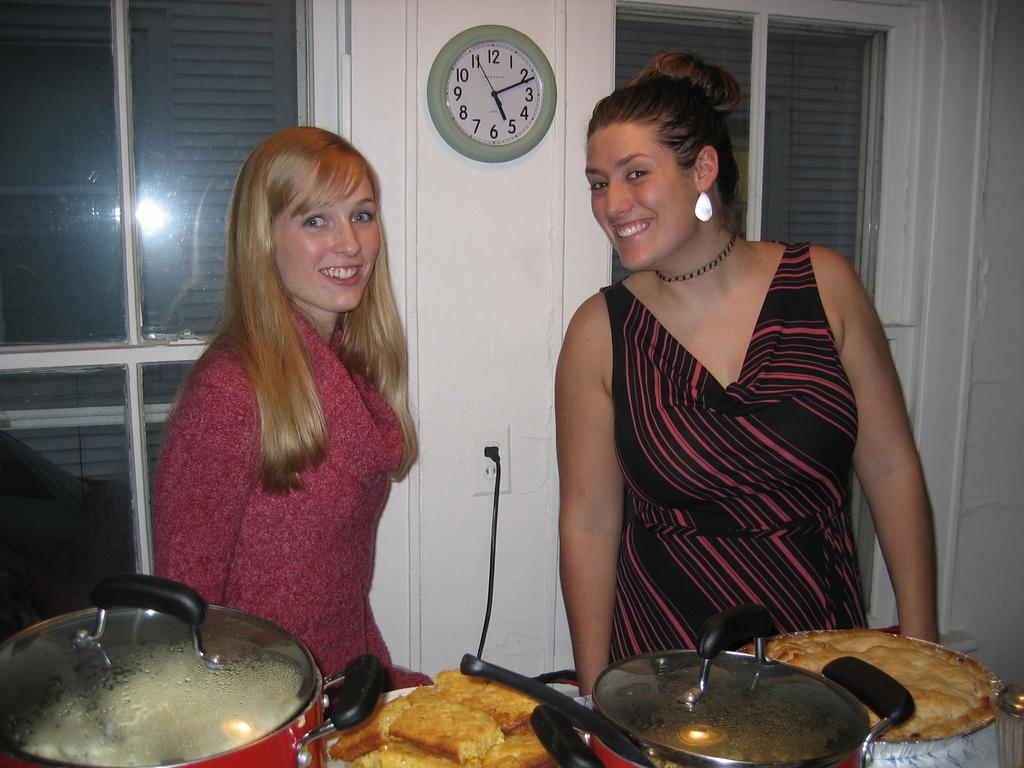How many women are in the image? There are two women in the image. What are the women doing in the image? The women are standing in the image. What can be seen in front of the women? There are eatables and pans in front of the women. What is attached to the wall behind the women? There is a clock attached to the wall behind the women. How does the cat help with the digestion of the eatables in the image? There is no cat present in the image, and therefore no assistance with digestion can be observed. 